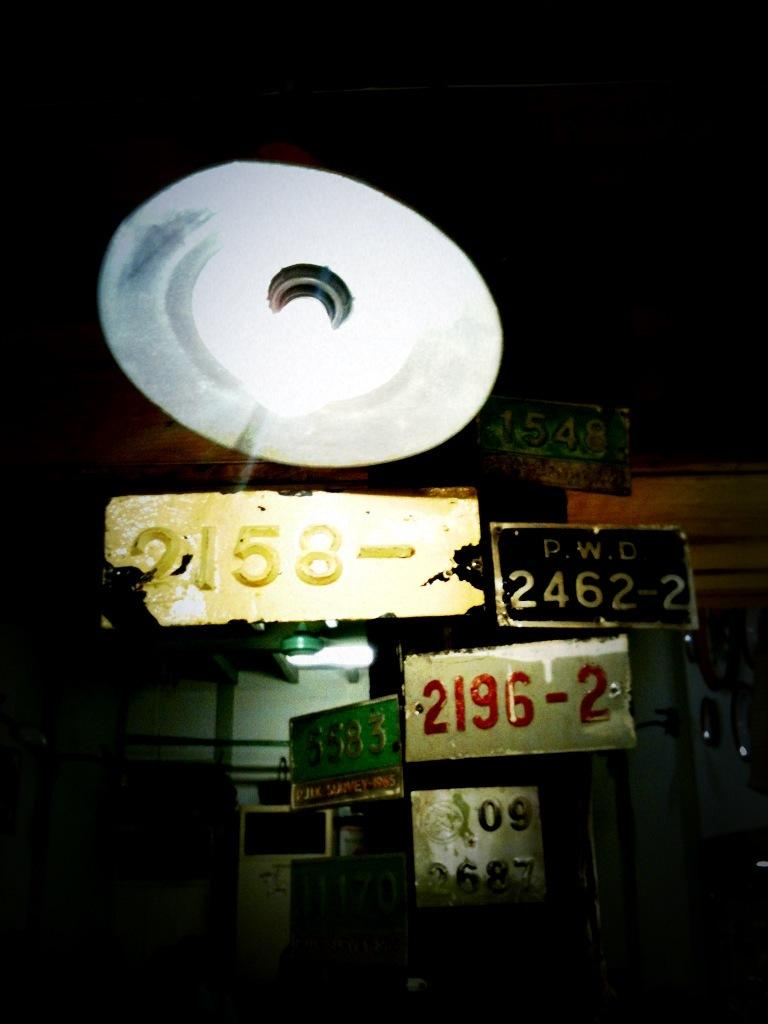Provide a one-sentence caption for the provided image. A 2196-2 license plate along with others posted on a wall. 